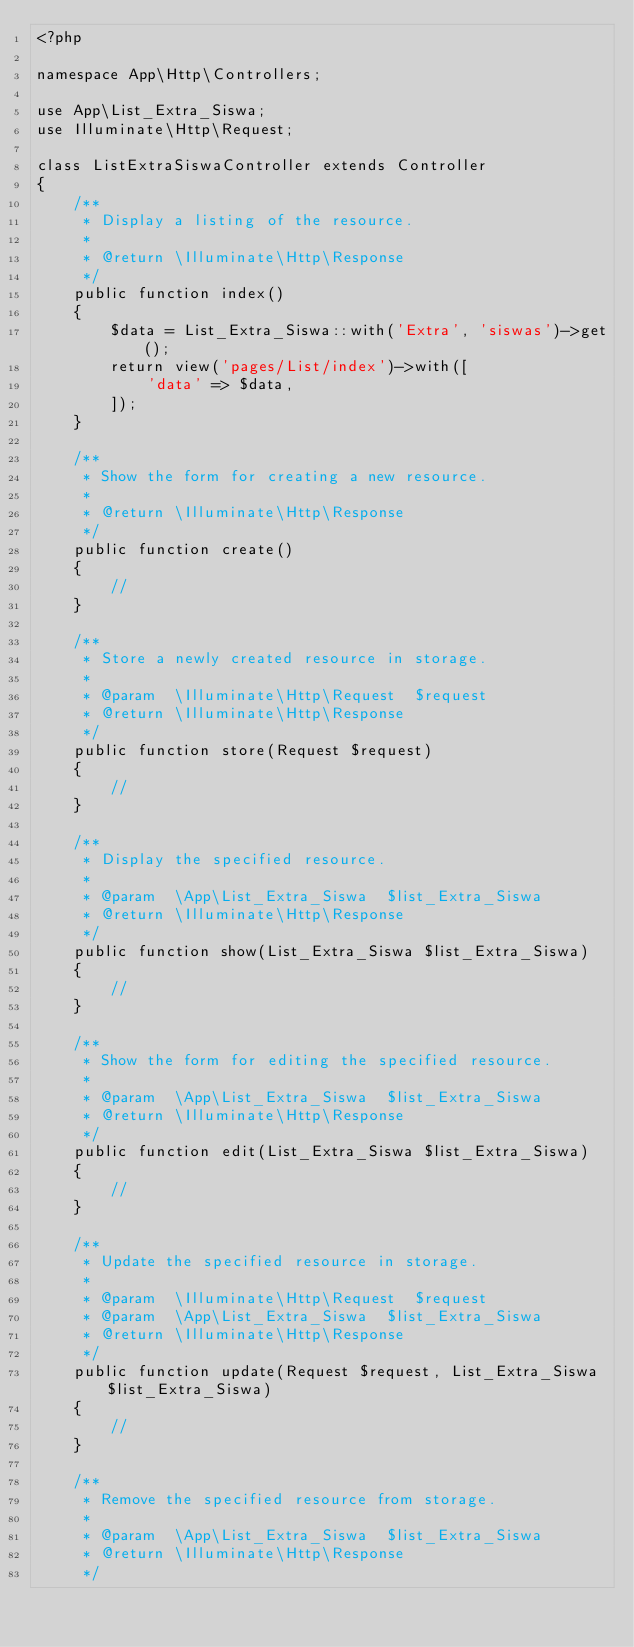Convert code to text. <code><loc_0><loc_0><loc_500><loc_500><_PHP_><?php

namespace App\Http\Controllers;

use App\List_Extra_Siswa;
use Illuminate\Http\Request;

class ListExtraSiswaController extends Controller
{
    /**
     * Display a listing of the resource.
     *
     * @return \Illuminate\Http\Response
     */
    public function index()
    {
        $data = List_Extra_Siswa::with('Extra', 'siswas')->get();
        return view('pages/List/index')->with([
            'data' => $data,
        ]);
    }

    /**
     * Show the form for creating a new resource.
     *
     * @return \Illuminate\Http\Response
     */
    public function create()
    {
        //
    }

    /**
     * Store a newly created resource in storage.
     *
     * @param  \Illuminate\Http\Request  $request
     * @return \Illuminate\Http\Response
     */
    public function store(Request $request)
    {
        //
    }

    /**
     * Display the specified resource.
     *
     * @param  \App\List_Extra_Siswa  $list_Extra_Siswa
     * @return \Illuminate\Http\Response
     */
    public function show(List_Extra_Siswa $list_Extra_Siswa)
    {
        //
    }

    /**
     * Show the form for editing the specified resource.
     *
     * @param  \App\List_Extra_Siswa  $list_Extra_Siswa
     * @return \Illuminate\Http\Response
     */
    public function edit(List_Extra_Siswa $list_Extra_Siswa)
    {
        //
    }

    /**
     * Update the specified resource in storage.
     *
     * @param  \Illuminate\Http\Request  $request
     * @param  \App\List_Extra_Siswa  $list_Extra_Siswa
     * @return \Illuminate\Http\Response
     */
    public function update(Request $request, List_Extra_Siswa $list_Extra_Siswa)
    {
        //
    }

    /**
     * Remove the specified resource from storage.
     *
     * @param  \App\List_Extra_Siswa  $list_Extra_Siswa
     * @return \Illuminate\Http\Response
     */</code> 